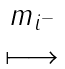<formula> <loc_0><loc_0><loc_500><loc_500>\begin{matrix} m _ { i ^ { - } } \\ \longmapsto \end{matrix}</formula> 